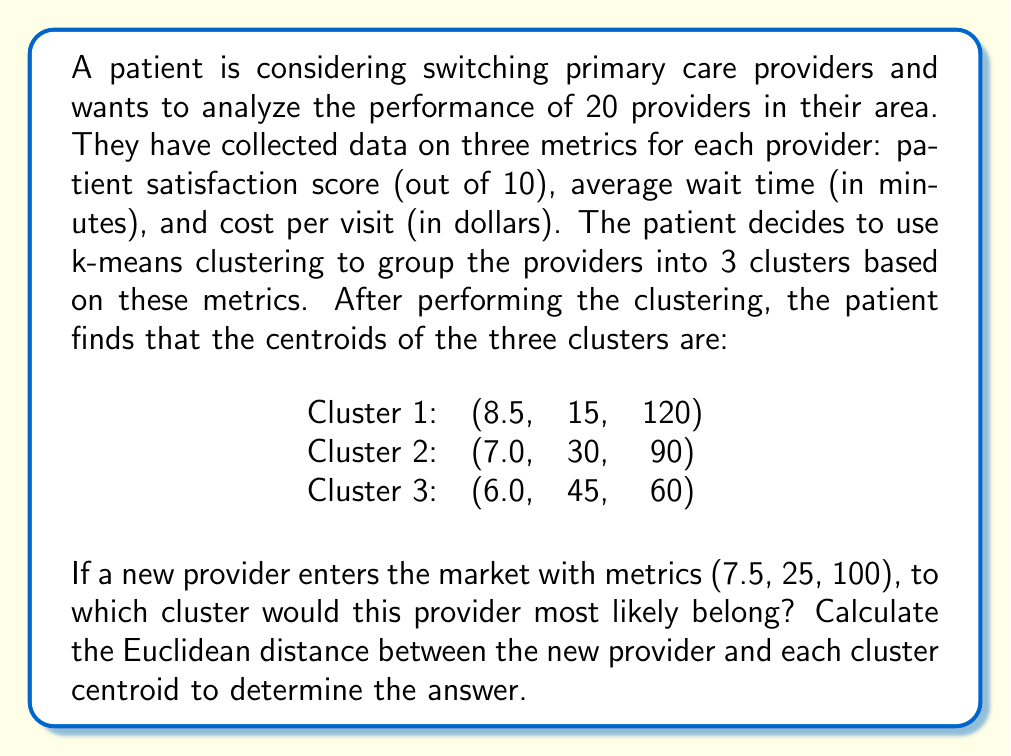Give your solution to this math problem. To solve this problem, we need to calculate the Euclidean distance between the new provider and each cluster centroid. The provider will belong to the cluster with the smallest distance.

The Euclidean distance in 3-dimensional space is given by the formula:

$$ d = \sqrt{(x_2 - x_1)^2 + (y_2 - y_1)^2 + (z_2 - z_1)^2} $$

Where $(x_1, y_1, z_1)$ is the new provider's coordinates and $(x_2, y_2, z_2)$ is the cluster centroid's coordinates.

Let's calculate the distance to each cluster:

1. Distance to Cluster 1 (8.5, 15, 120):
$$ d_1 = \sqrt{(8.5 - 7.5)^2 + (15 - 25)^2 + (120 - 100)^2} $$
$$ d_1 = \sqrt{1^2 + (-10)^2 + 20^2} $$
$$ d_1 = \sqrt{1 + 100 + 400} = \sqrt{501} \approx 22.38 $$

2. Distance to Cluster 2 (7.0, 30, 90):
$$ d_2 = \sqrt{(7.0 - 7.5)^2 + (30 - 25)^2 + (90 - 100)^2} $$
$$ d_2 = \sqrt{(-0.5)^2 + 5^2 + (-10)^2} $$
$$ d_2 = \sqrt{0.25 + 25 + 100} = \sqrt{125.25} \approx 11.19 $$

3. Distance to Cluster 3 (6.0, 45, 60):
$$ d_3 = \sqrt{(6.0 - 7.5)^2 + (45 - 25)^2 + (60 - 100)^2} $$
$$ d_3 = \sqrt{(-1.5)^2 + 20^2 + (-40)^2} $$
$$ d_3 = \sqrt{2.25 + 400 + 1600} = \sqrt{2002.25} \approx 44.75 $$

The smallest distance is $d_2 \approx 11.19$, which corresponds to Cluster 2.
Answer: The new provider with metrics (7.5, 25, 100) would most likely belong to Cluster 2, as it has the smallest Euclidean distance (approximately 11.19) to the centroid of this cluster. 